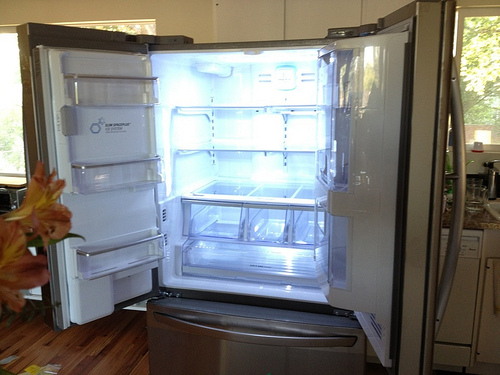What time of day does it seem to be based on the lighting within the picture? The warm and soft quality of light permeating through the large window suggests the photo was taken during the golden hours of the early morning. Could you describe the full contents visible in the refrigerator? The refrigerator is largely empty, with only a few plastic storage containers on the shelves, possibly indicating a recent cleaning or the need for grocery shopping. 